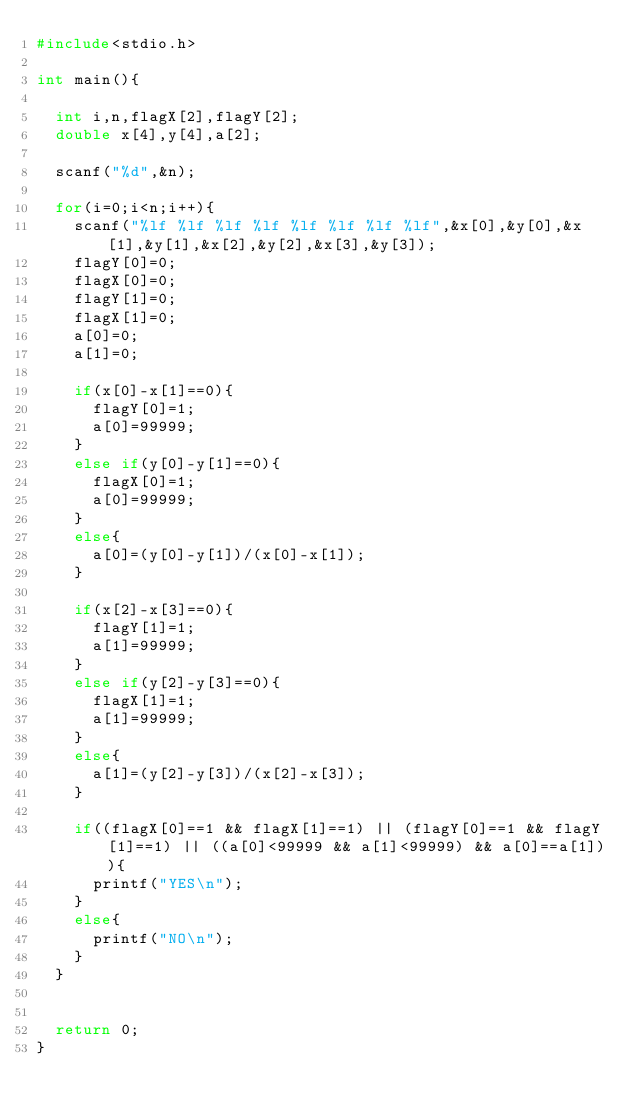Convert code to text. <code><loc_0><loc_0><loc_500><loc_500><_C_>#include<stdio.h>

int main(){

	int i,n,flagX[2],flagY[2];
	double x[4],y[4],a[2];

	scanf("%d",&n);

	for(i=0;i<n;i++){
		scanf("%lf %lf %lf %lf %lf %lf %lf %lf",&x[0],&y[0],&x[1],&y[1],&x[2],&y[2],&x[3],&y[3]);
		flagY[0]=0;
		flagX[0]=0;
		flagY[1]=0;
		flagX[1]=0;
		a[0]=0;
		a[1]=0;

		if(x[0]-x[1]==0){
			flagY[0]=1;
			a[0]=99999;
		}
		else if(y[0]-y[1]==0){
			flagX[0]=1;
			a[0]=99999;
		}
		else{
			a[0]=(y[0]-y[1])/(x[0]-x[1]);
		}

		if(x[2]-x[3]==0){
			flagY[1]=1;
			a[1]=99999;
		}
		else if(y[2]-y[3]==0){
			flagX[1]=1;
			a[1]=99999;
		}
		else{
			a[1]=(y[2]-y[3])/(x[2]-x[3]);
		}

		if((flagX[0]==1 && flagX[1]==1) || (flagY[0]==1 && flagY[1]==1) || ((a[0]<99999 && a[1]<99999) && a[0]==a[1])){
			printf("YES\n");
		}
		else{
			printf("NO\n");
		}
	}


	return 0;
}</code> 